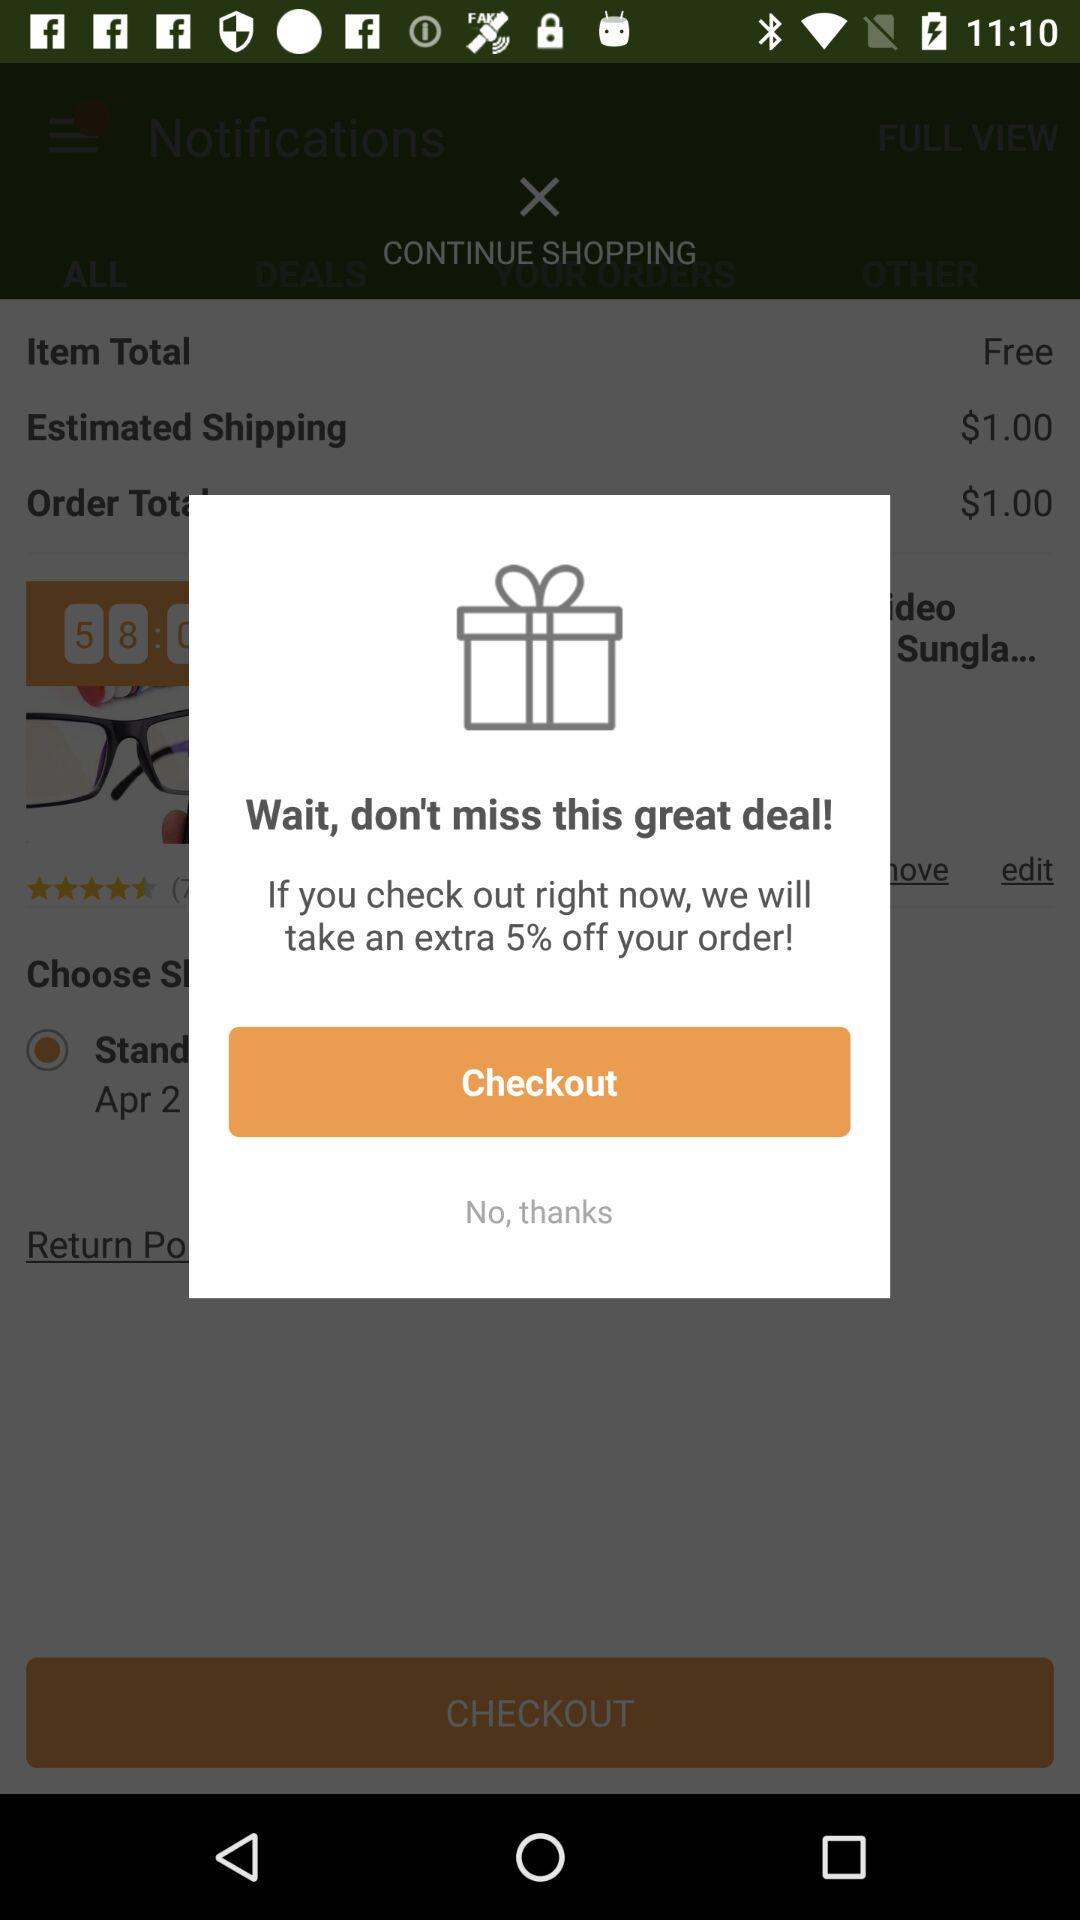How much of an extra discount can I get when I check out right now? You can get an extra 5% discount. 